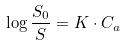<formula> <loc_0><loc_0><loc_500><loc_500>\log \frac { S _ { 0 } } { S } = K \cdot C _ { a }</formula> 